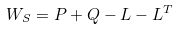Convert formula to latex. <formula><loc_0><loc_0><loc_500><loc_500>W _ { S } = P + Q - L - L ^ { T }</formula> 